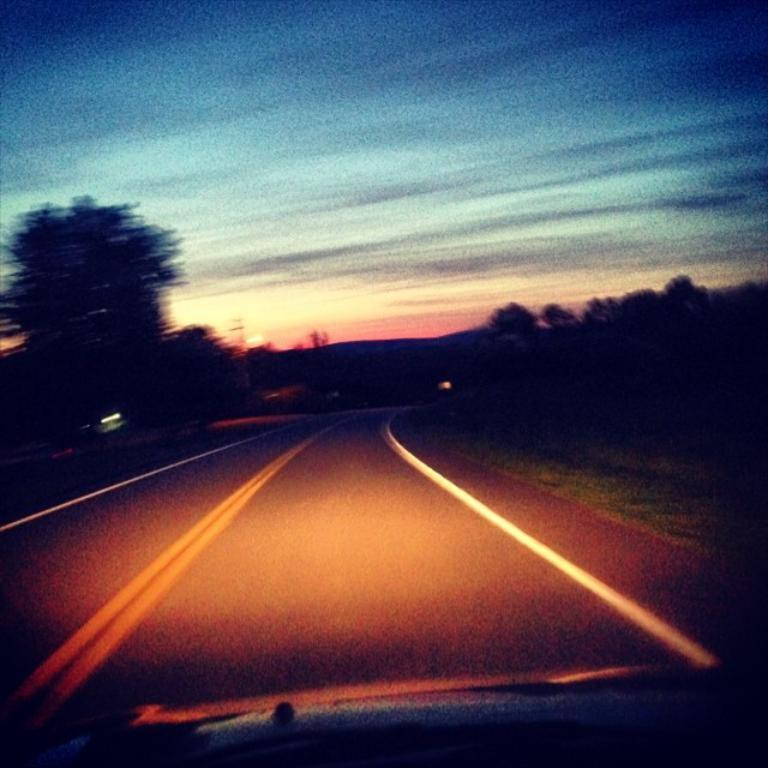What is the main subject of the image? There is a vehicle in the image. What is the setting of the image? There is a road in the image. What can be seen in the background of the image? There are trees in the background of the image. What is the color of the sky in the image? The sky is blue and white in color. What language does the uncle speak in the image? There is no uncle present in the image, and therefore no language can be attributed to him. 